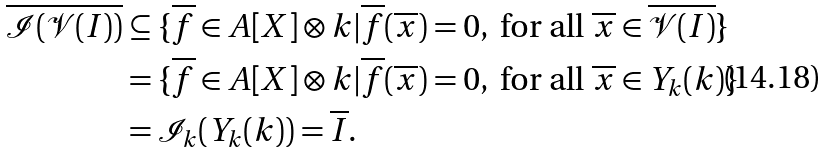Convert formula to latex. <formula><loc_0><loc_0><loc_500><loc_500>\overline { \mathcal { I } ( \mathcal { V } ( I ) ) } & \subseteq \{ \overline { f } \in A [ X ] \otimes k | \overline { f } ( \overline { x } ) = 0 , \text { for all } \overline { x } \in \overline { \mathcal { V } ( I ) } \} \\ & = \{ \overline { f } \in A [ X ] \otimes k | \overline { f } ( \overline { x } ) = 0 , \text { for all } \overline { x } \in Y _ { k } ( k ) \} \\ & = \mathcal { I } _ { k } ( Y _ { k } ( k ) ) = \overline { I } .</formula> 